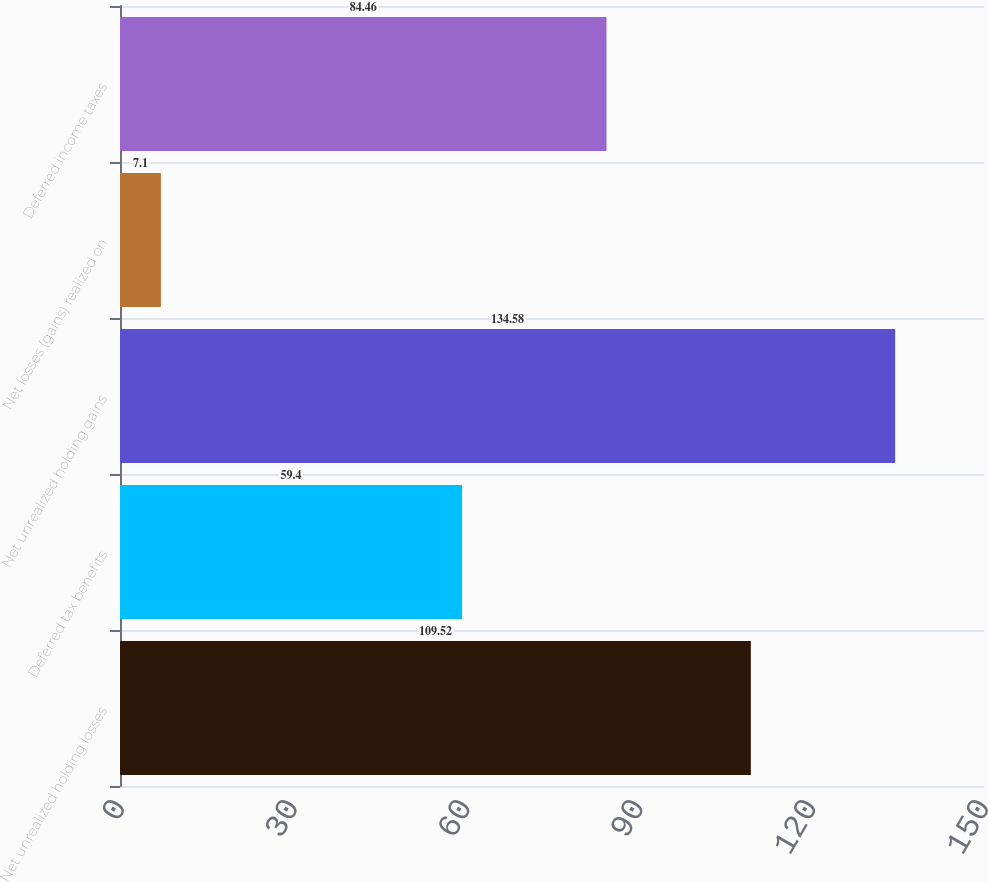Convert chart. <chart><loc_0><loc_0><loc_500><loc_500><bar_chart><fcel>Net unrealized holding losses<fcel>Deferred tax benefits<fcel>Net unrealized holding gains<fcel>Net losses (gains) realized on<fcel>Deferred income taxes<nl><fcel>109.52<fcel>59.4<fcel>134.58<fcel>7.1<fcel>84.46<nl></chart> 